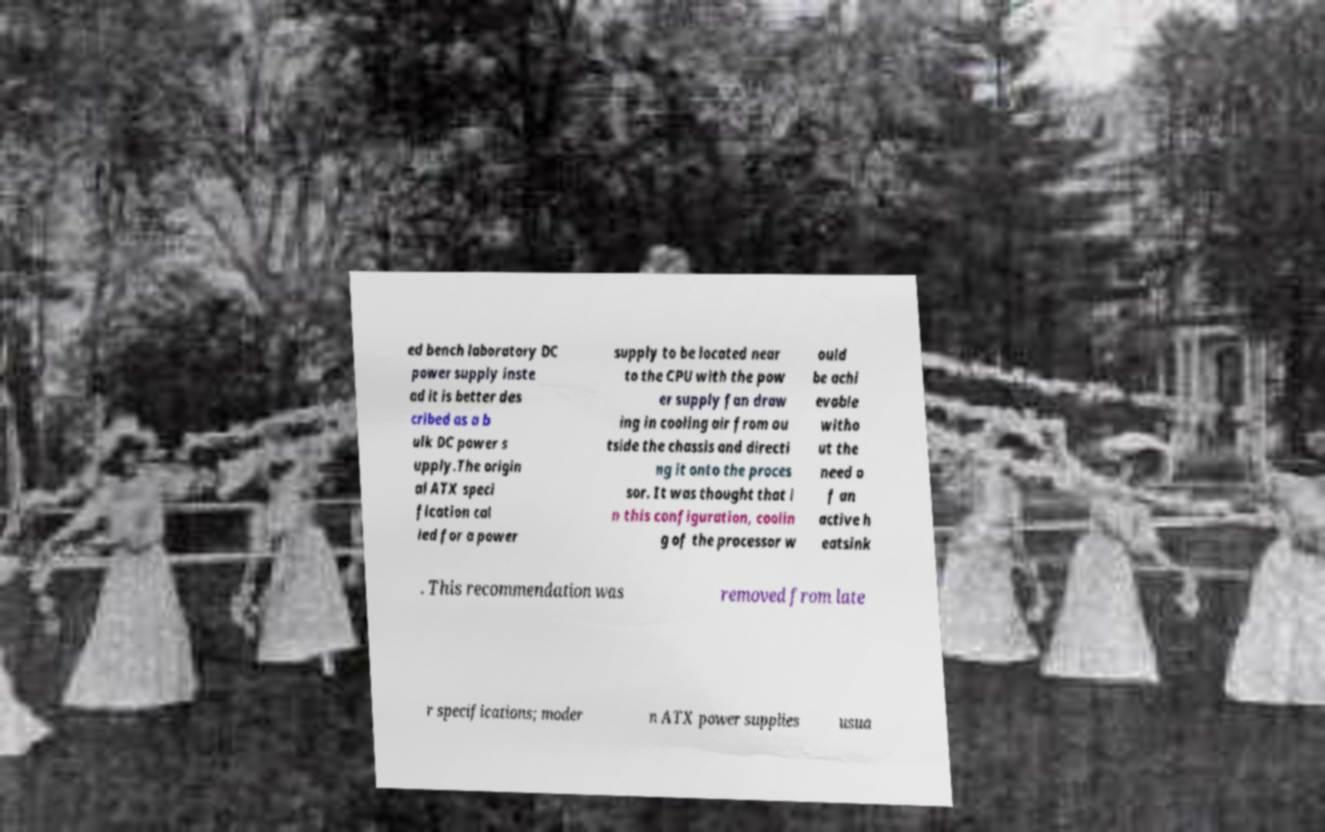Can you accurately transcribe the text from the provided image for me? ed bench laboratory DC power supply inste ad it is better des cribed as a b ulk DC power s upply.The origin al ATX speci fication cal led for a power supply to be located near to the CPU with the pow er supply fan draw ing in cooling air from ou tside the chassis and directi ng it onto the proces sor. It was thought that i n this configuration, coolin g of the processor w ould be achi evable witho ut the need o f an active h eatsink . This recommendation was removed from late r specifications; moder n ATX power supplies usua 